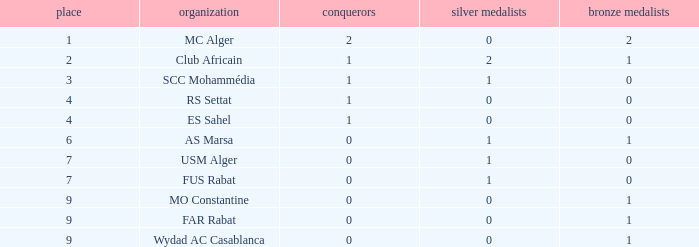Which Third has Runners-up of 0, and Winners of 0, and a Club of far rabat? 1.0. Can you give me this table as a dict? {'header': ['place', 'organization', 'conquerors', 'silver medalists', 'bronze medalists'], 'rows': [['1', 'MC Alger', '2', '0', '2'], ['2', 'Club Africain', '1', '2', '1'], ['3', 'SCC Mohammédia', '1', '1', '0'], ['4', 'RS Settat', '1', '0', '0'], ['4', 'ES Sahel', '1', '0', '0'], ['6', 'AS Marsa', '0', '1', '1'], ['7', 'USM Alger', '0', '1', '0'], ['7', 'FUS Rabat', '0', '1', '0'], ['9', 'MO Constantine', '0', '0', '1'], ['9', 'FAR Rabat', '0', '0', '1'], ['9', 'Wydad AC Casablanca', '0', '0', '1']]} 